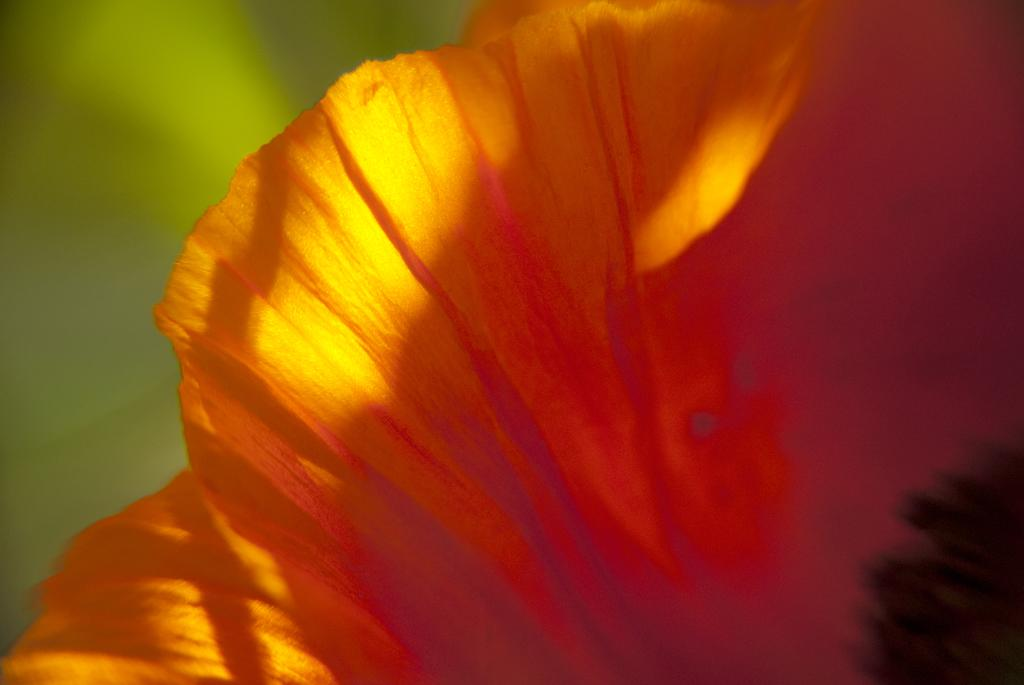What type of flower is present in the image? There is an orange-colored flower in the image. What color is present on the left side of the image? There is green color on the left side of the image. What type of store can be seen in the background of the image? There is no store present in the image; it only features an orange-colored flower and green color on the left side. 